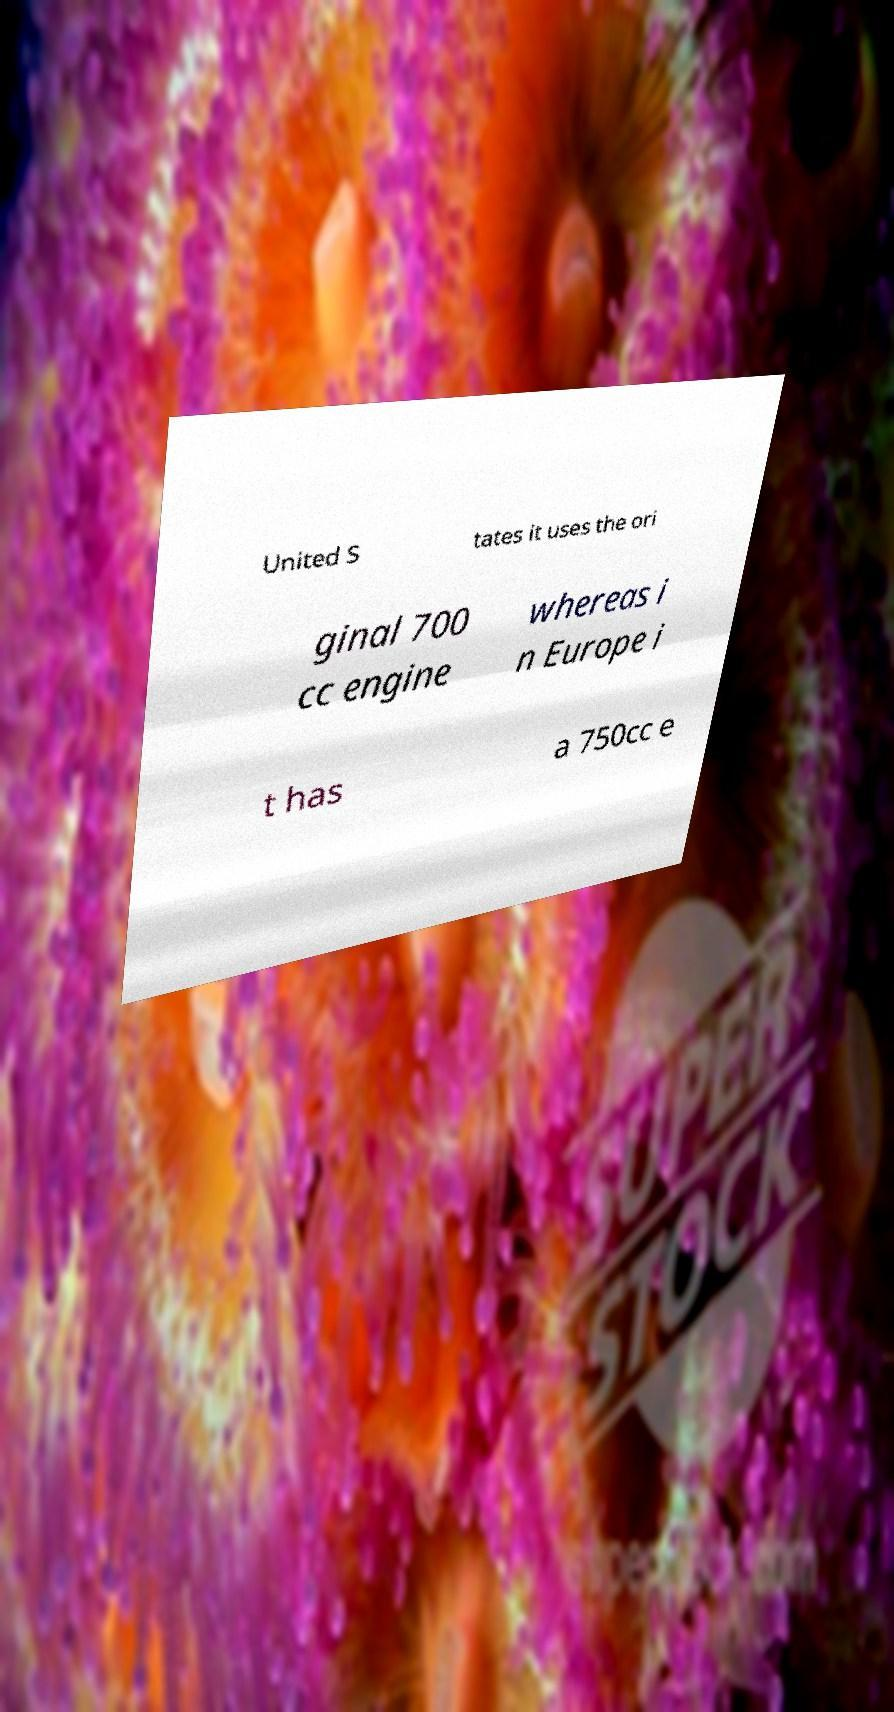Could you assist in decoding the text presented in this image and type it out clearly? United S tates it uses the ori ginal 700 cc engine whereas i n Europe i t has a 750cc e 